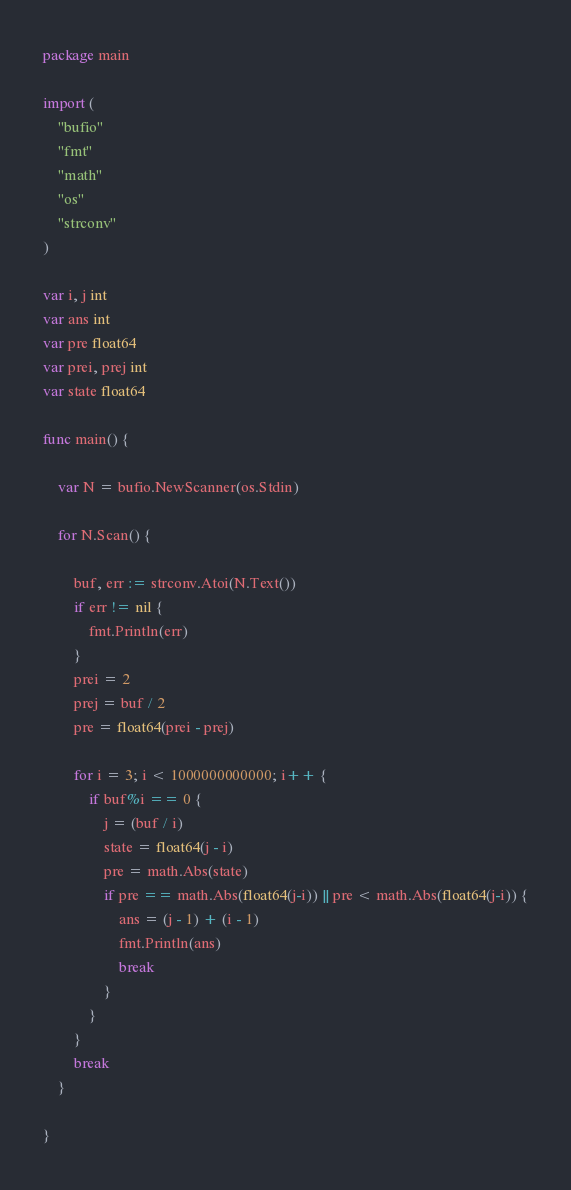Convert code to text. <code><loc_0><loc_0><loc_500><loc_500><_Go_>package main

import (
	"bufio"
	"fmt"
	"math"
	"os"
	"strconv"
)

var i, j int
var ans int
var pre float64
var prei, prej int
var state float64

func main() {

	var N = bufio.NewScanner(os.Stdin)

	for N.Scan() {

		buf, err := strconv.Atoi(N.Text())
		if err != nil {
			fmt.Println(err)
		}
		prei = 2
		prej = buf / 2
		pre = float64(prei - prej)

		for i = 3; i < 1000000000000; i++ {
			if buf%i == 0 {
				j = (buf / i)
				state = float64(j - i)
				pre = math.Abs(state)
				if pre == math.Abs(float64(j-i)) || pre < math.Abs(float64(j-i)) {
					ans = (j - 1) + (i - 1)
					fmt.Println(ans)
					break
				}
			}
		}
		break
	}

}</code> 